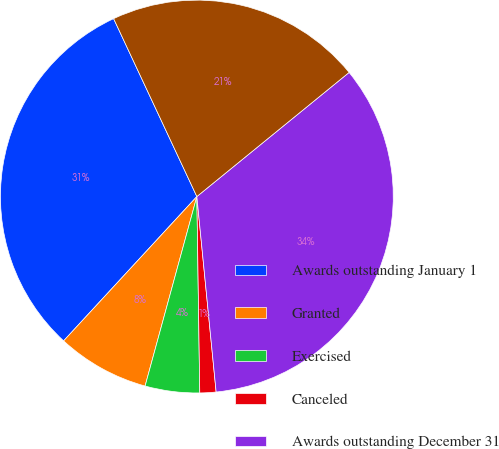Convert chart. <chart><loc_0><loc_0><loc_500><loc_500><pie_chart><fcel>Awards outstanding January 1<fcel>Granted<fcel>Exercised<fcel>Canceled<fcel>Awards outstanding December 31<fcel>Awards exercisable December 31<nl><fcel>31.17%<fcel>7.62%<fcel>4.48%<fcel>1.33%<fcel>34.32%<fcel>21.08%<nl></chart> 